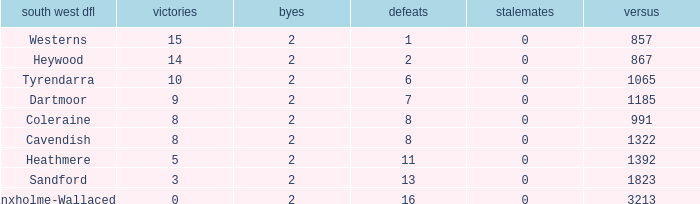Which draws have an average of 14 wins? 0.0. 